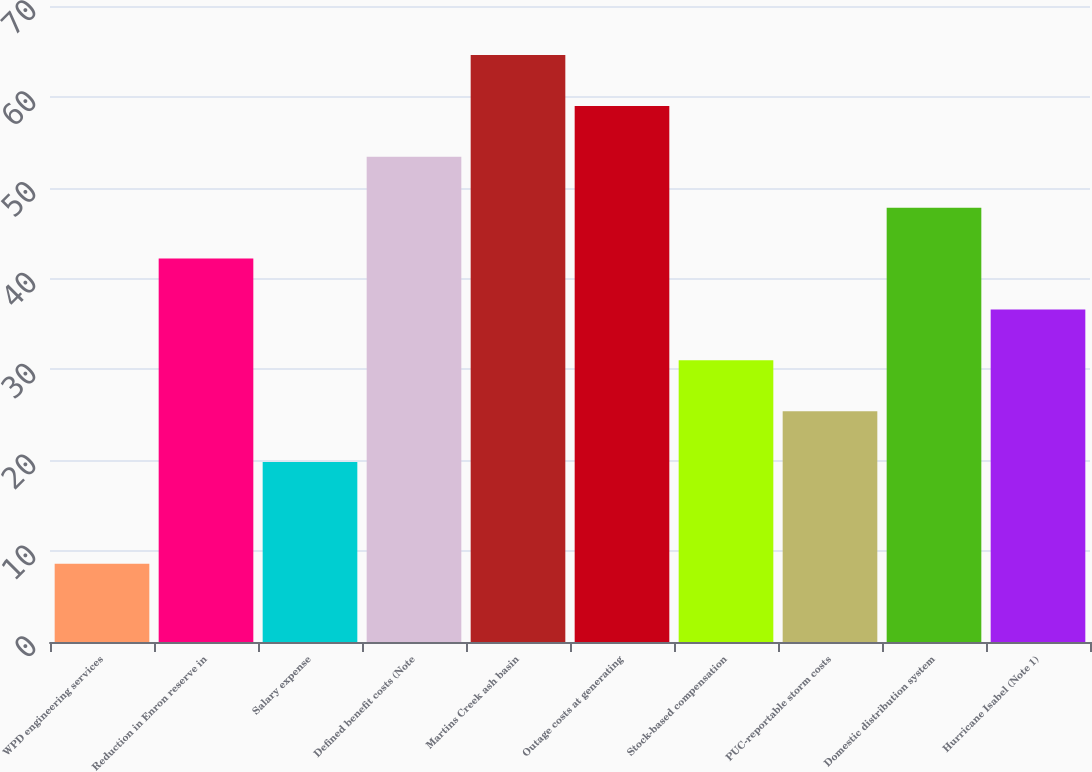Convert chart. <chart><loc_0><loc_0><loc_500><loc_500><bar_chart><fcel>WPD engineering services<fcel>Reduction in Enron reserve in<fcel>Salary expense<fcel>Defined benefit costs (Note<fcel>Martins Creek ash basin<fcel>Outage costs at generating<fcel>Stock-based compensation<fcel>PUC-reportable storm costs<fcel>Domestic distribution system<fcel>Hurricane Isabel (Note 1)<nl><fcel>8.6<fcel>42.2<fcel>19.8<fcel>53.4<fcel>64.6<fcel>59<fcel>31<fcel>25.4<fcel>47.8<fcel>36.6<nl></chart> 